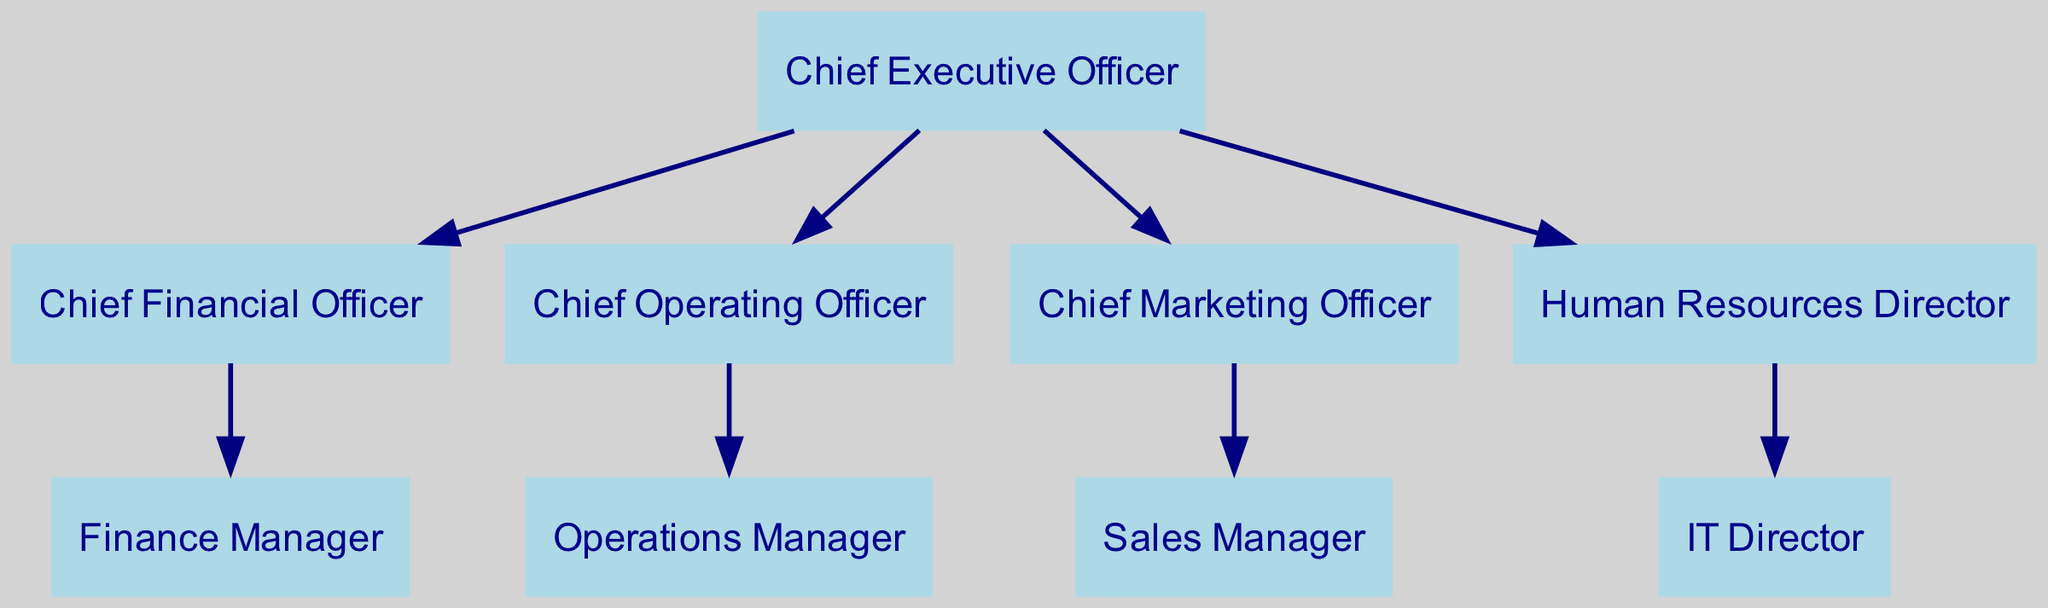What is the label of the topmost node in the diagram? The topmost node in the diagram is the one labeled as "Chief Executive Officer". This is determined by looking at the hierarchy starting from the CEO, who is situated directly at the top of the directed graph.
Answer: Chief Executive Officer How many total nodes are present in the diagram? To find the total nodes, we count each unique entity represented in the diagram. There are 9 distinct positions such as CEO, CFO, COO, CMO, HRD, ITD, Sales Manager, Finance Manager, and Operations Manager.
Answer: 9 Who does the Chief Executive Officer report to? The Chief Executive Officer is the highest position in the diagram; thus, he does not report to anyone. Instead, all other positions report to him directly.
Answer: No one How many edges originate from the Chief Executive Officer? The edges originating from the Chief Executive Officer can be counted directly from the diagram. There are four outgoing edges representing the CFO, COO, CMO, and HRD reporting directly to the CEO.
Answer: 4 Which position is directly under the Chief Financial Officer? The position directly under the Chief Financial Officer is the Finance Manager. This can be identified by tracing the edge that comes from the CFO down to the Finance Manager.
Answer: Finance Manager What is the relationship between the Chief Operating Officer and the Operations Manager? The Chief Operating Officer has a direct reporting relationship with the Operations Manager, as indicated by a directed edge connecting COO to Operations Manager in the diagram.
Answer: Reports to Which position oversees the IT Director? The IT Director is overseen by the Human Resources Director, as indicated by the edge from HRD to ITD in the diagram.
Answer: Human Resources Director How many positions report directly to the Chief Marketing Officer? Upon inspection of the diagram, there is only one position that reports directly to the Chief Marketing Officer, which is the Sales Manager, as represented by a single outgoing edge from CMO to Sales Manager.
Answer: 1 Is the Human Resources Director connected to any other position besides the IT Director? The Human Resources Director is only connected to the IT Director as per the diagram, which shows a sole edge emanating from HRD heading to ITD with no other direct connections noted.
Answer: No Which nodes have no outgoing edges? To find the nodes with no outgoing edges, we look for positions that do not point to any other roles. The nodes without outgoing edges in this diagram are IT Director, Finance Manager, Sales Manager, and Operations Manager.
Answer: IT Director, Finance Manager, Sales Manager, Operations Manager 